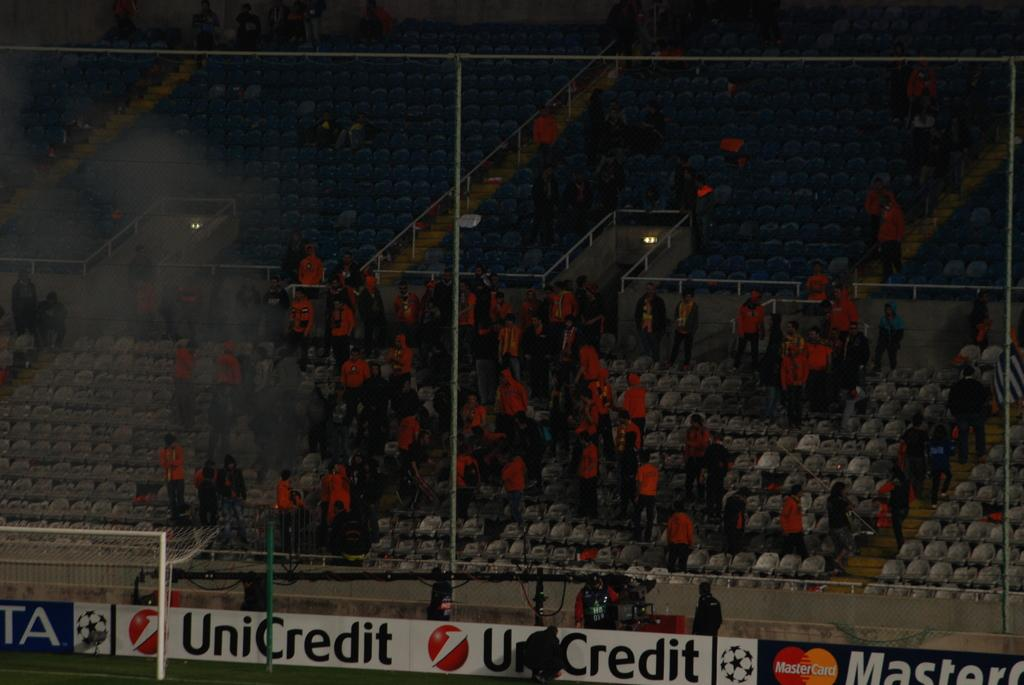Provide a one-sentence caption for the provided image. A large crowd in a stadium with a banner that says UniCredit. 